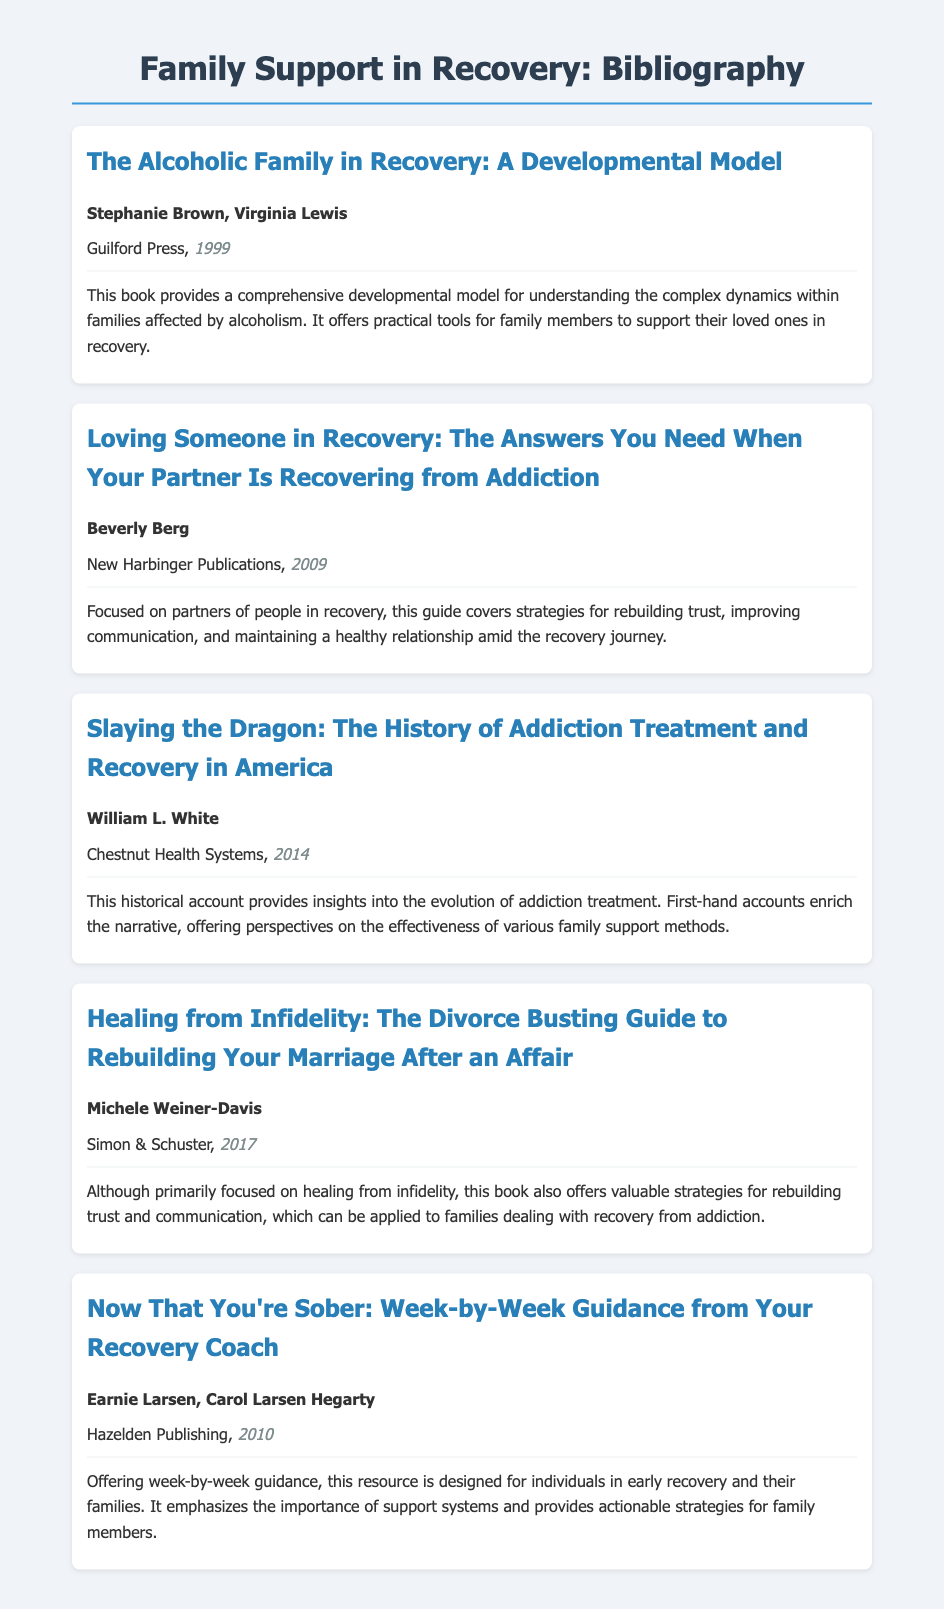What is the title of the book by Stephanie Brown and Virginia Lewis? The title is found in the bibliography item which lists the authors and their work together.
Answer: The Alcoholic Family in Recovery: A Developmental Model Who authored "Loving Someone in Recovery"? This information is given in the author section of the second bibliography item.
Answer: Beverly Berg In what year was "Slaying the Dragon" published? The publication year is clearly stated in the citation of the specific bibliography item.
Answer: 2014 Which publisher released "Now That You're Sober"? The publisher's name appears alongside the authors and year in the bibliography entry.
Answer: Hazelden Publishing What topic does "Healing from Infidelity" primarily focus on? The description highlights the main theme of the book regarding relationships, which is evident in the title.
Answer: Healing from infidelity How many bibliography items are listed in total? This can be counted by assessing the number of individual bibliography entries visible in the document.
Answer: 5 Which book mentions strategies for rebuilding trust? The descriptions of the relevant entries provide hints at content related to trust rebuilding.
Answer: Healing from Infidelity What is the overarching theme of the bibliography? The titles and descriptions of the works collectively point toward recovery processes and family support.
Answer: Family support in recovery 